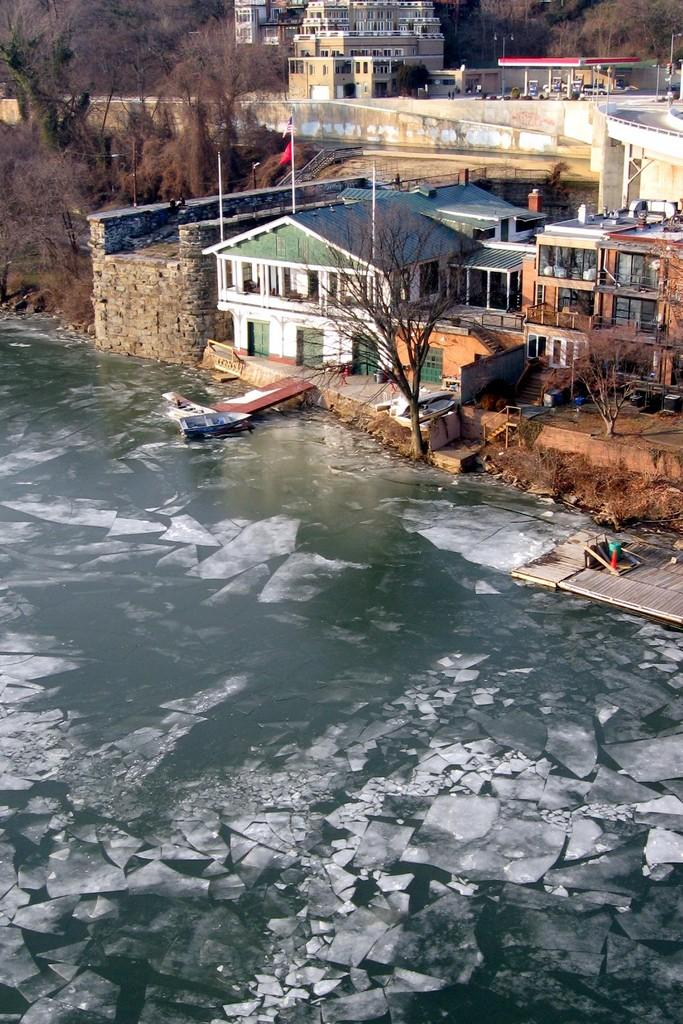What type of natural feature is present in the image? There is a frozen lake in the image. What structure is located behind the lake? There is a wooden platform behind the lake. What type of vegetation can be seen in the image? Trees are present in the image. What type of human-made structures are visible in the image? Houses are visible in the image. What type of mitten is being used to frame the houses in the image? There is no mitten present in the image, nor is anything being used to frame the houses. 